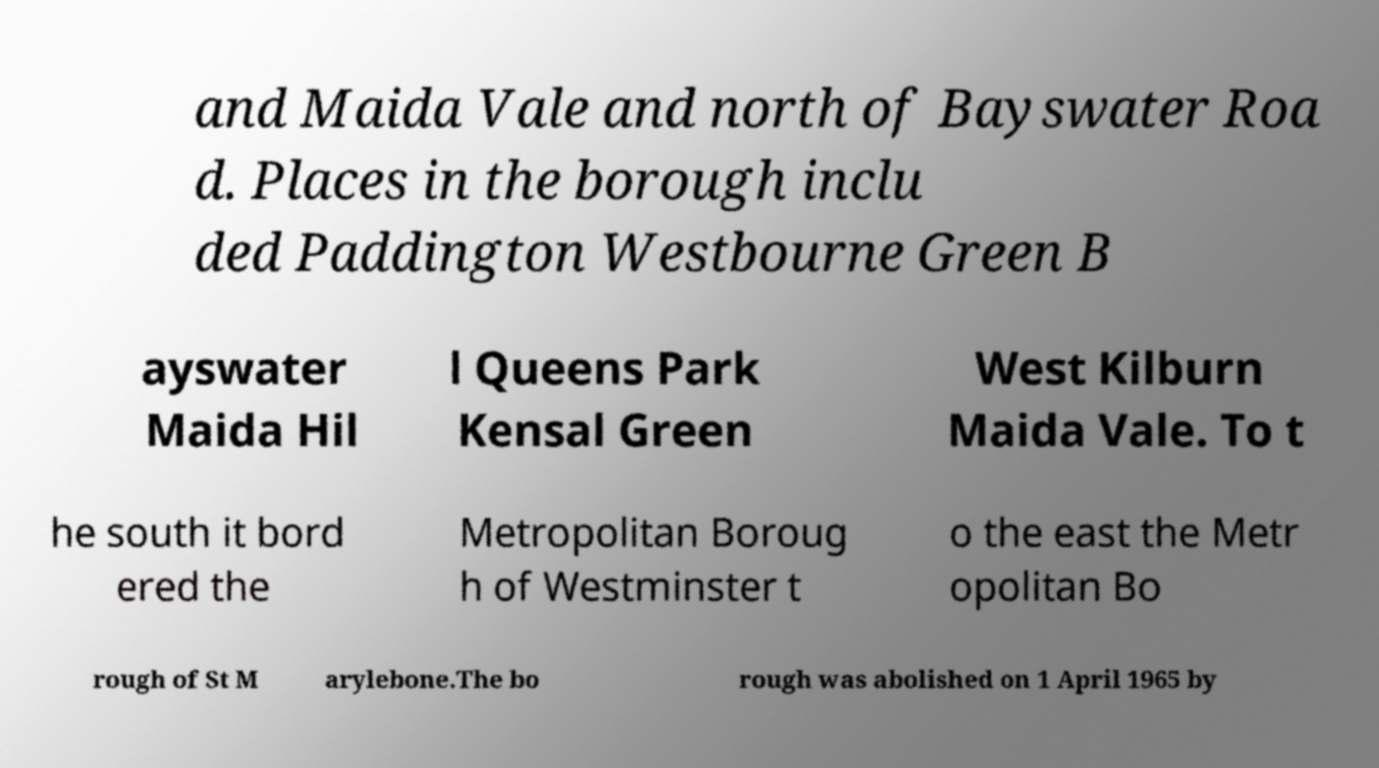There's text embedded in this image that I need extracted. Can you transcribe it verbatim? and Maida Vale and north of Bayswater Roa d. Places in the borough inclu ded Paddington Westbourne Green B ayswater Maida Hil l Queens Park Kensal Green West Kilburn Maida Vale. To t he south it bord ered the Metropolitan Boroug h of Westminster t o the east the Metr opolitan Bo rough of St M arylebone.The bo rough was abolished on 1 April 1965 by 